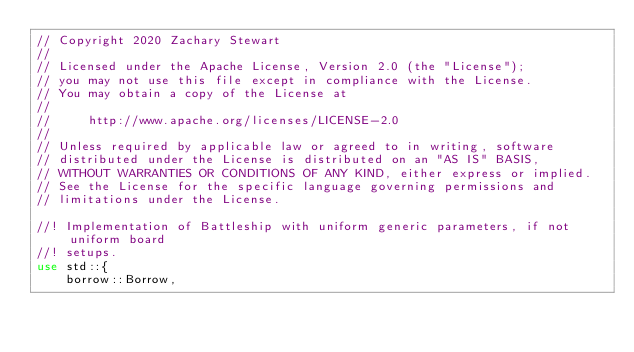Convert code to text. <code><loc_0><loc_0><loc_500><loc_500><_Rust_>// Copyright 2020 Zachary Stewart
//
// Licensed under the Apache License, Version 2.0 (the "License");
// you may not use this file except in compliance with the License.
// You may obtain a copy of the License at
//
//     http://www.apache.org/licenses/LICENSE-2.0
//
// Unless required by applicable law or agreed to in writing, software
// distributed under the License is distributed on an "AS IS" BASIS,
// WITHOUT WARRANTIES OR CONDITIONS OF ANY KIND, either express or implied.
// See the License for the specific language governing permissions and
// limitations under the License.

//! Implementation of Battleship with uniform generic parameters, if not uniform board
//! setups.
use std::{
    borrow::Borrow,</code> 